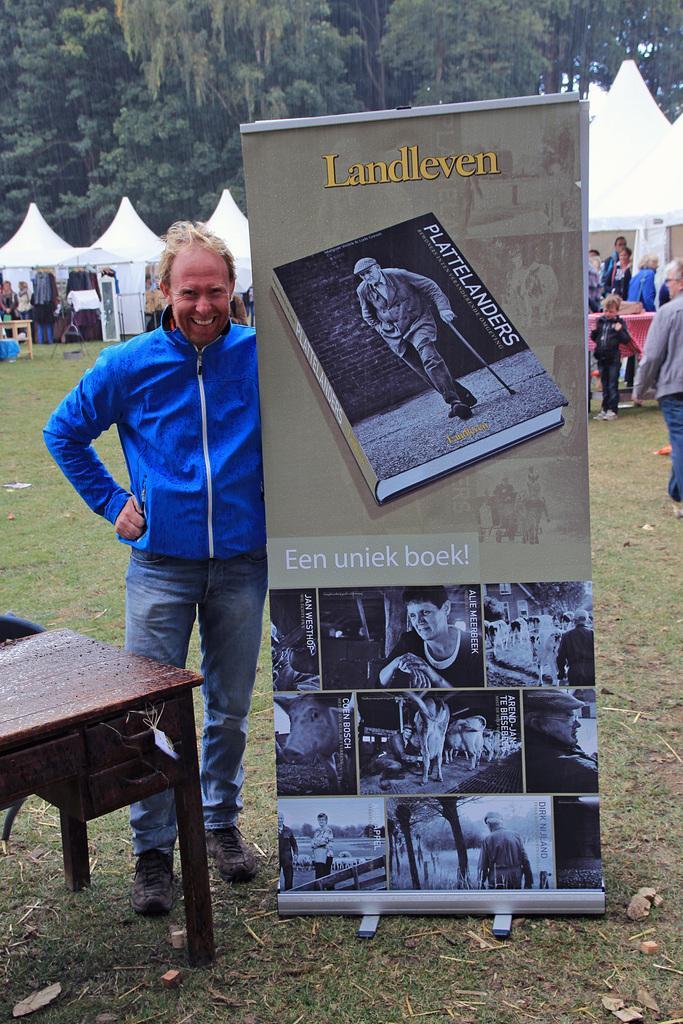Can you describe this image briefly? As we can see in the image, there are few persons on the ground. The person who is standing in the front is holding a banner in his hand. In the front there is a bench. In the background there are trees. 